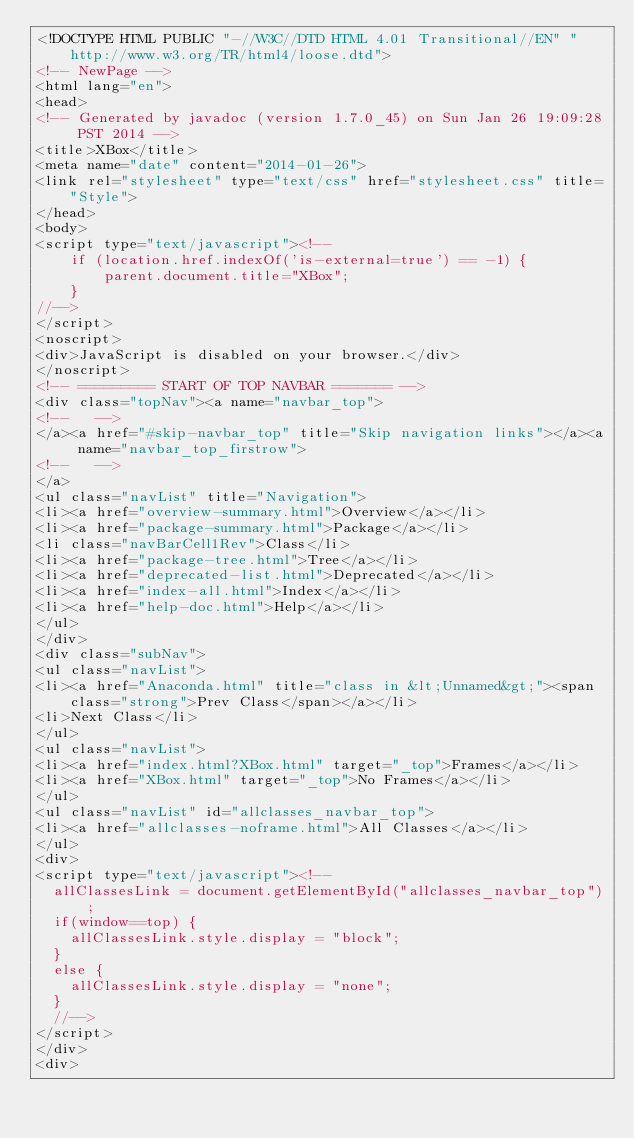Convert code to text. <code><loc_0><loc_0><loc_500><loc_500><_HTML_><!DOCTYPE HTML PUBLIC "-//W3C//DTD HTML 4.01 Transitional//EN" "http://www.w3.org/TR/html4/loose.dtd">
<!-- NewPage -->
<html lang="en">
<head>
<!-- Generated by javadoc (version 1.7.0_45) on Sun Jan 26 19:09:28 PST 2014 -->
<title>XBox</title>
<meta name="date" content="2014-01-26">
<link rel="stylesheet" type="text/css" href="stylesheet.css" title="Style">
</head>
<body>
<script type="text/javascript"><!--
    if (location.href.indexOf('is-external=true') == -1) {
        parent.document.title="XBox";
    }
//-->
</script>
<noscript>
<div>JavaScript is disabled on your browser.</div>
</noscript>
<!-- ========= START OF TOP NAVBAR ======= -->
<div class="topNav"><a name="navbar_top">
<!--   -->
</a><a href="#skip-navbar_top" title="Skip navigation links"></a><a name="navbar_top_firstrow">
<!--   -->
</a>
<ul class="navList" title="Navigation">
<li><a href="overview-summary.html">Overview</a></li>
<li><a href="package-summary.html">Package</a></li>
<li class="navBarCell1Rev">Class</li>
<li><a href="package-tree.html">Tree</a></li>
<li><a href="deprecated-list.html">Deprecated</a></li>
<li><a href="index-all.html">Index</a></li>
<li><a href="help-doc.html">Help</a></li>
</ul>
</div>
<div class="subNav">
<ul class="navList">
<li><a href="Anaconda.html" title="class in &lt;Unnamed&gt;"><span class="strong">Prev Class</span></a></li>
<li>Next Class</li>
</ul>
<ul class="navList">
<li><a href="index.html?XBox.html" target="_top">Frames</a></li>
<li><a href="XBox.html" target="_top">No Frames</a></li>
</ul>
<ul class="navList" id="allclasses_navbar_top">
<li><a href="allclasses-noframe.html">All Classes</a></li>
</ul>
<div>
<script type="text/javascript"><!--
  allClassesLink = document.getElementById("allclasses_navbar_top");
  if(window==top) {
    allClassesLink.style.display = "block";
  }
  else {
    allClassesLink.style.display = "none";
  }
  //-->
</script>
</div>
<div></code> 